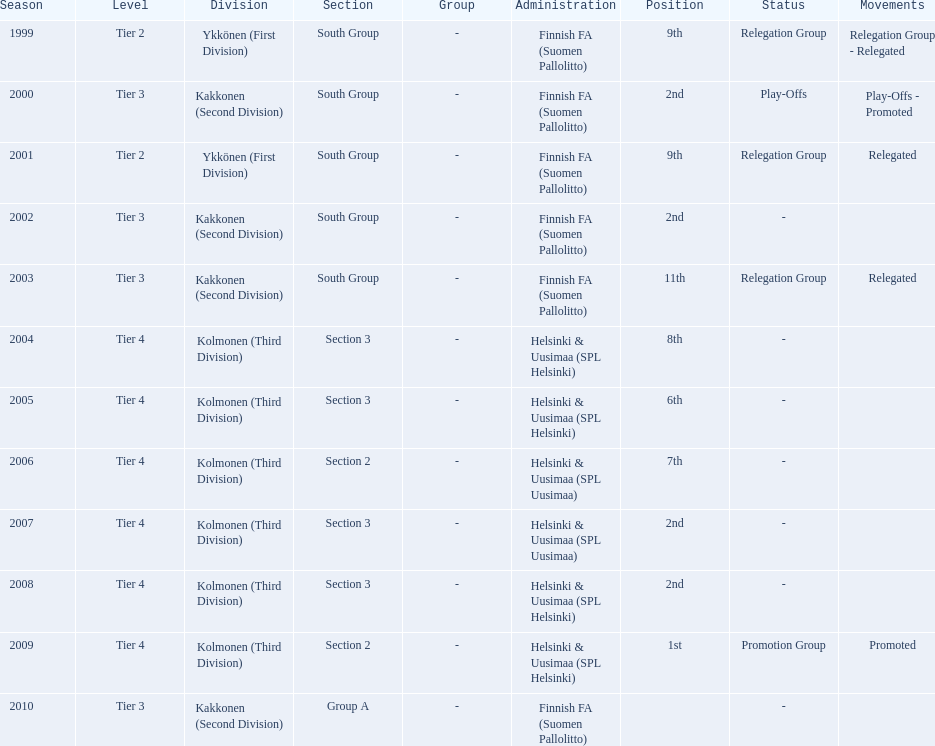Of the third division, how many were in section3? 4. 